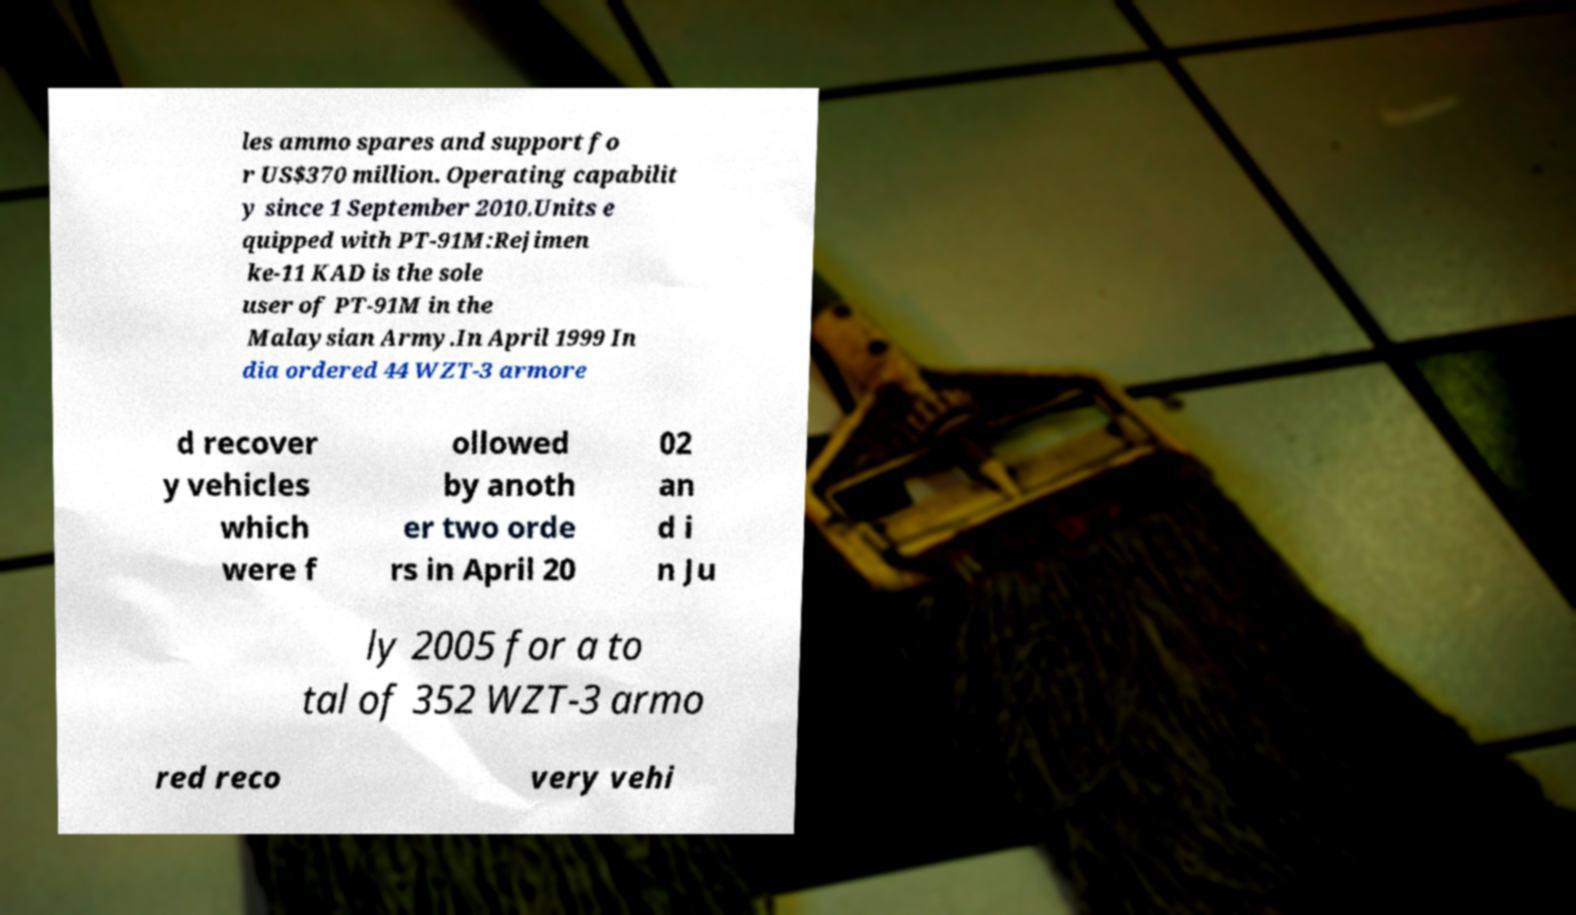I need the written content from this picture converted into text. Can you do that? les ammo spares and support fo r US$370 million. Operating capabilit y since 1 September 2010.Units e quipped with PT-91M:Rejimen ke-11 KAD is the sole user of PT-91M in the Malaysian Army.In April 1999 In dia ordered 44 WZT-3 armore d recover y vehicles which were f ollowed by anoth er two orde rs in April 20 02 an d i n Ju ly 2005 for a to tal of 352 WZT-3 armo red reco very vehi 